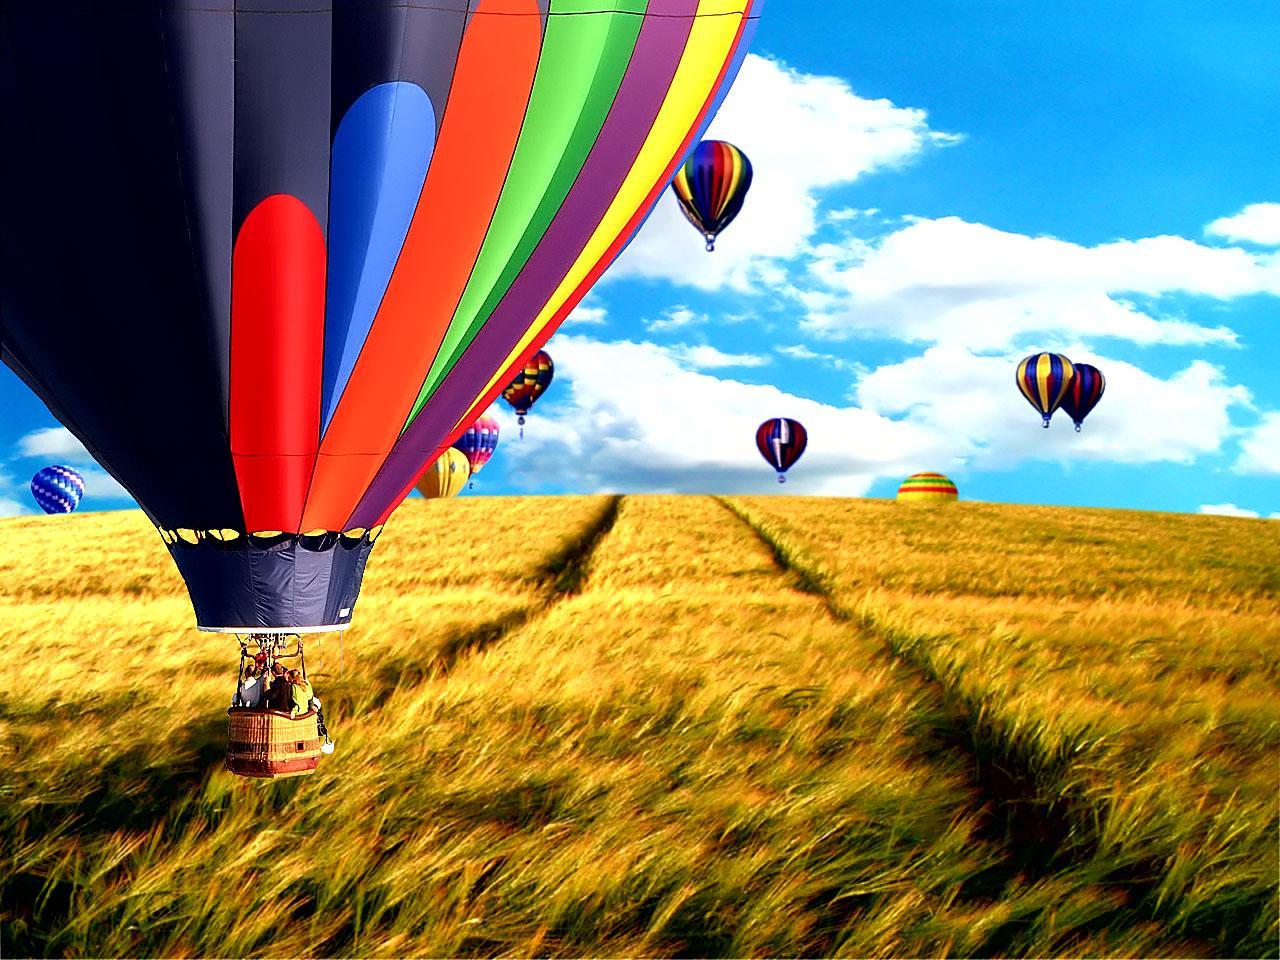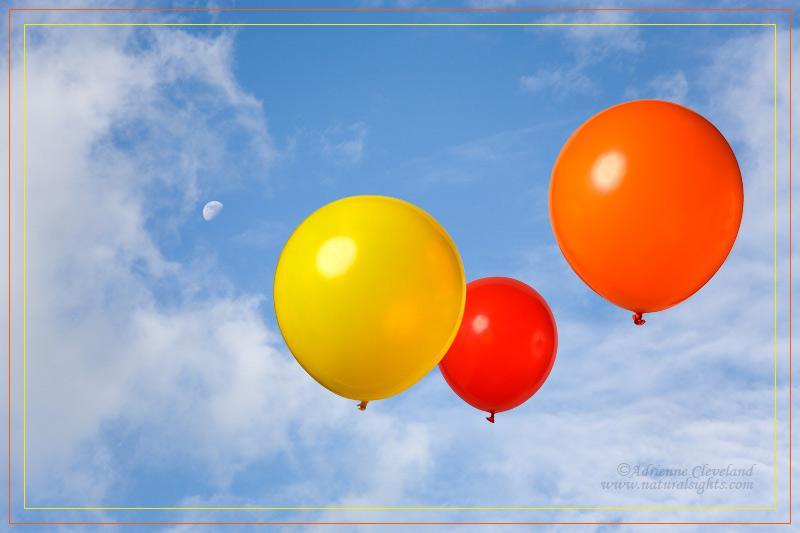The first image is the image on the left, the second image is the image on the right. Examine the images to the left and right. Is the description "An image shows at least one person being lifted by means of balloon." accurate? Answer yes or no. Yes. The first image is the image on the left, the second image is the image on the right. For the images shown, is this caption "There are two other colored balloons with a yellow balloon in the right image." true? Answer yes or no. Yes. 